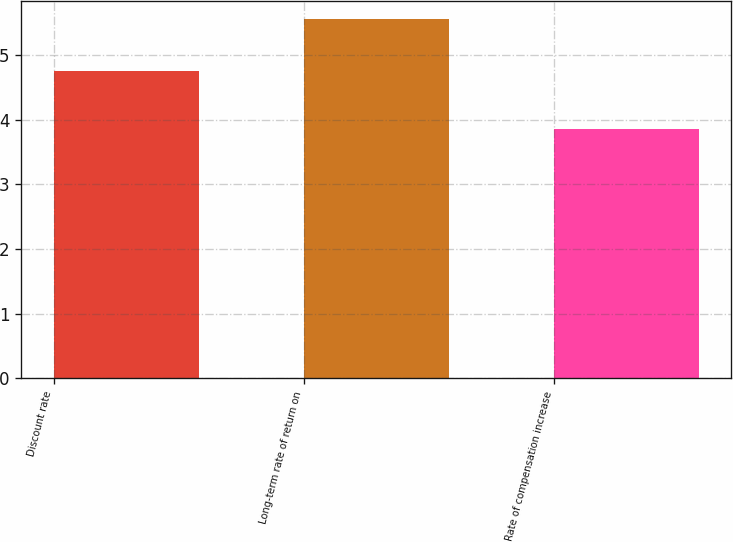<chart> <loc_0><loc_0><loc_500><loc_500><bar_chart><fcel>Discount rate<fcel>Long-term rate of return on<fcel>Rate of compensation increase<nl><fcel>4.75<fcel>5.55<fcel>3.85<nl></chart> 